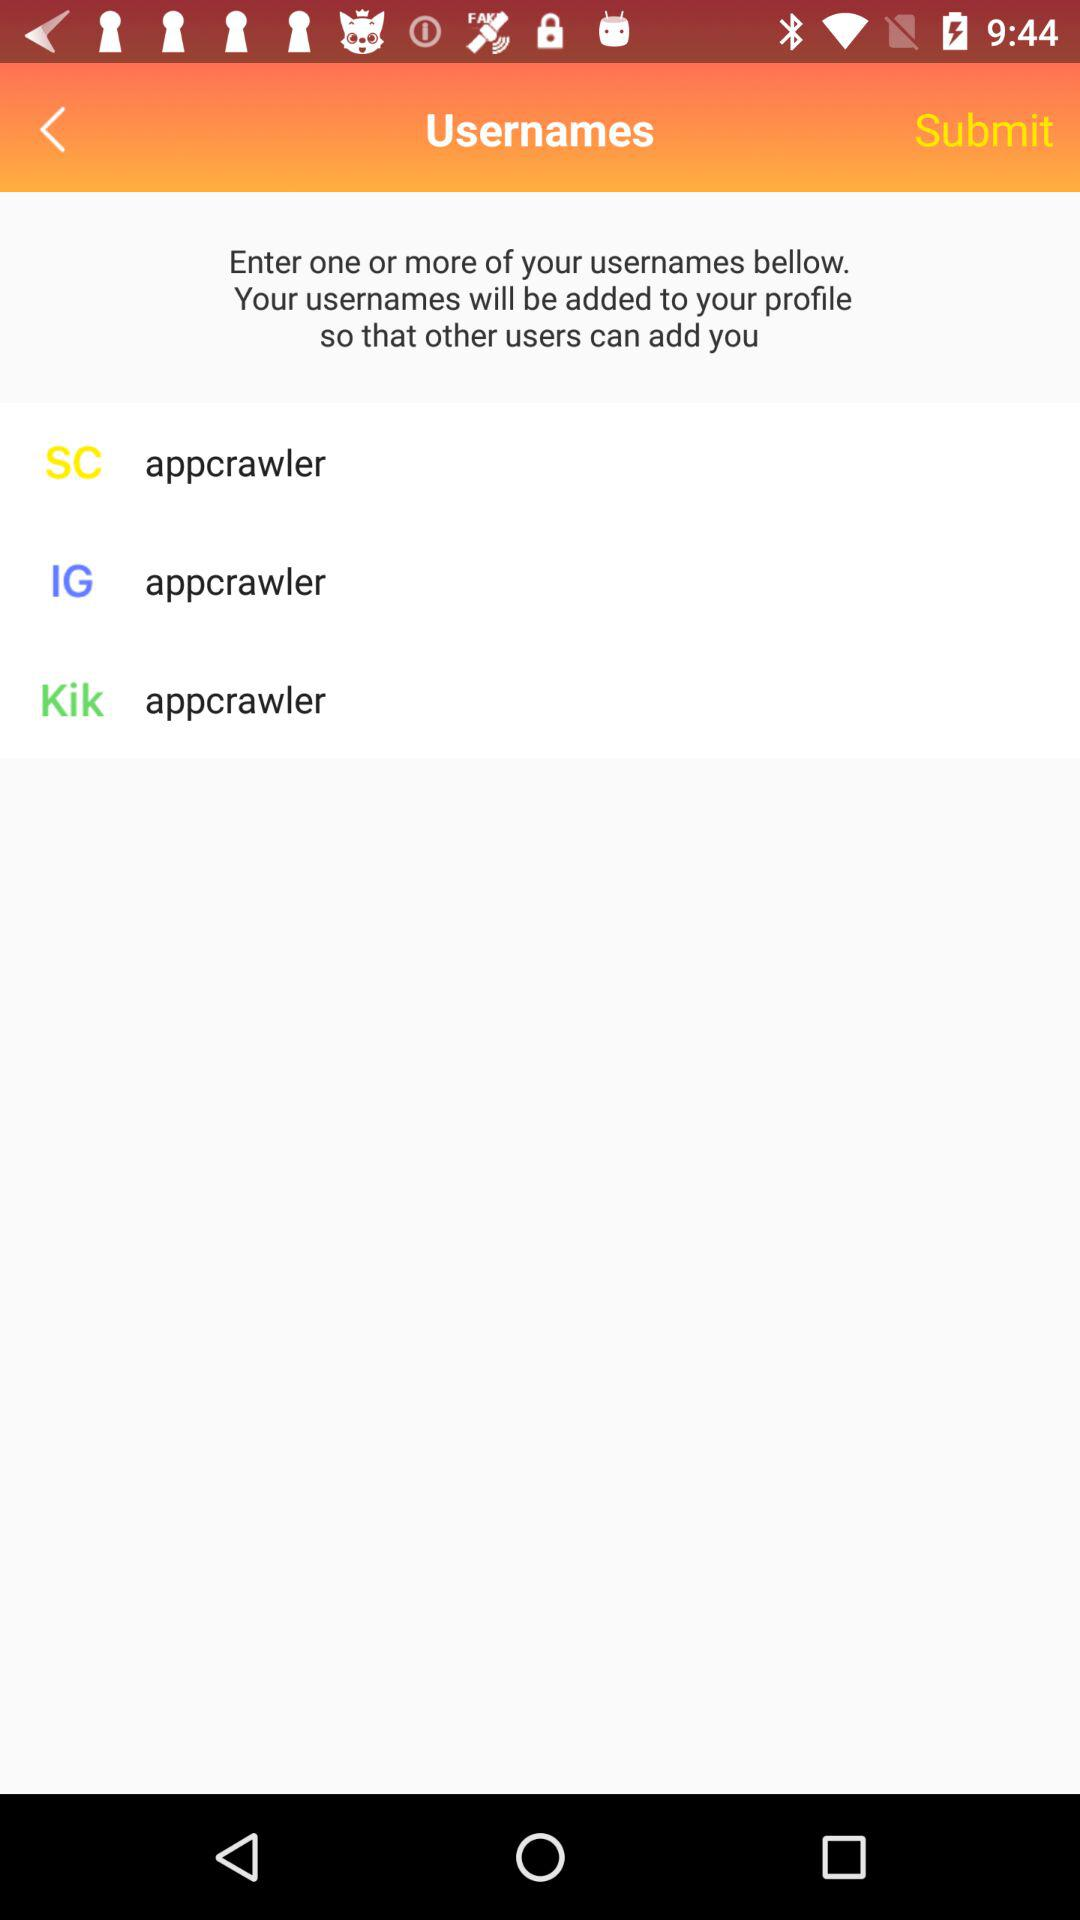How many usernames have been entered?
Answer the question using a single word or phrase. 3 